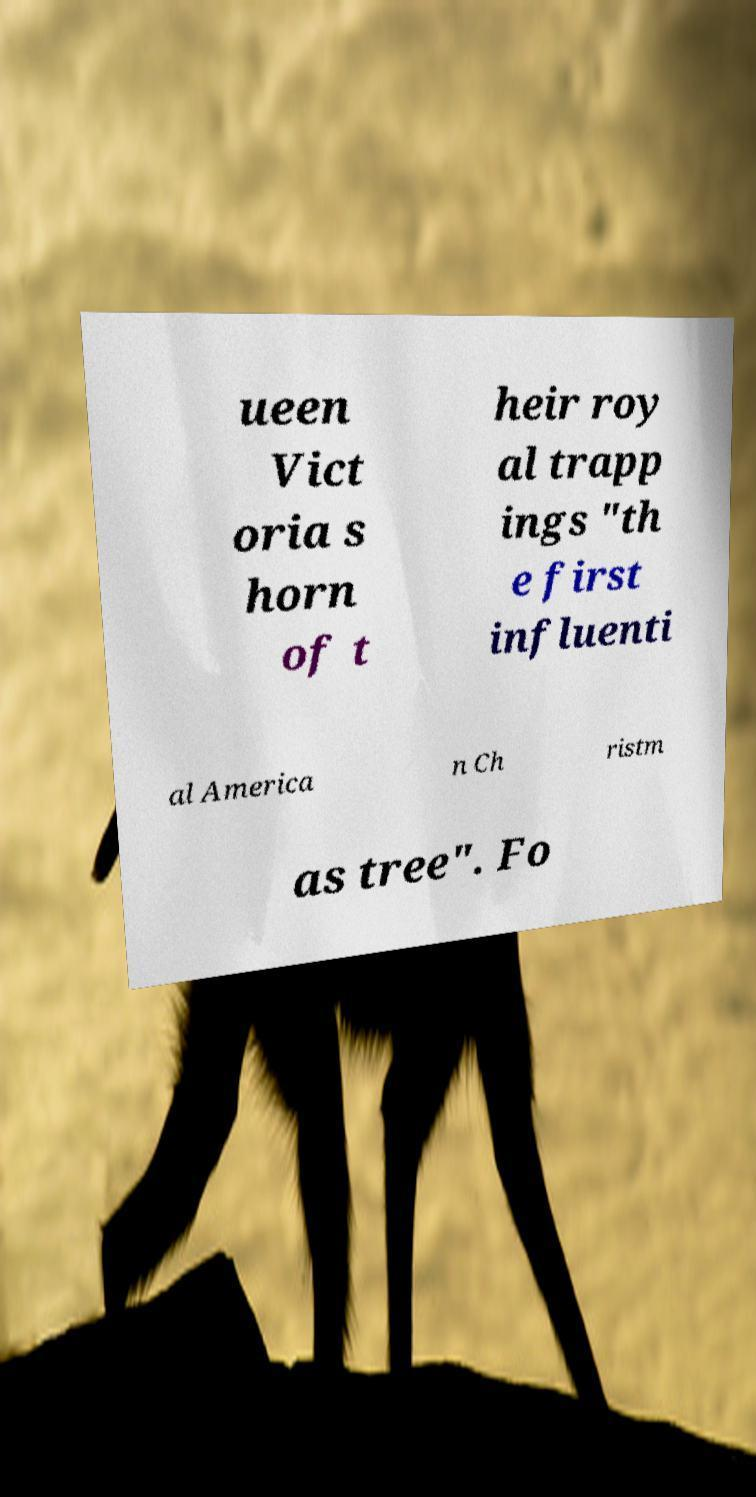What messages or text are displayed in this image? I need them in a readable, typed format. ueen Vict oria s horn of t heir roy al trapp ings "th e first influenti al America n Ch ristm as tree". Fo 